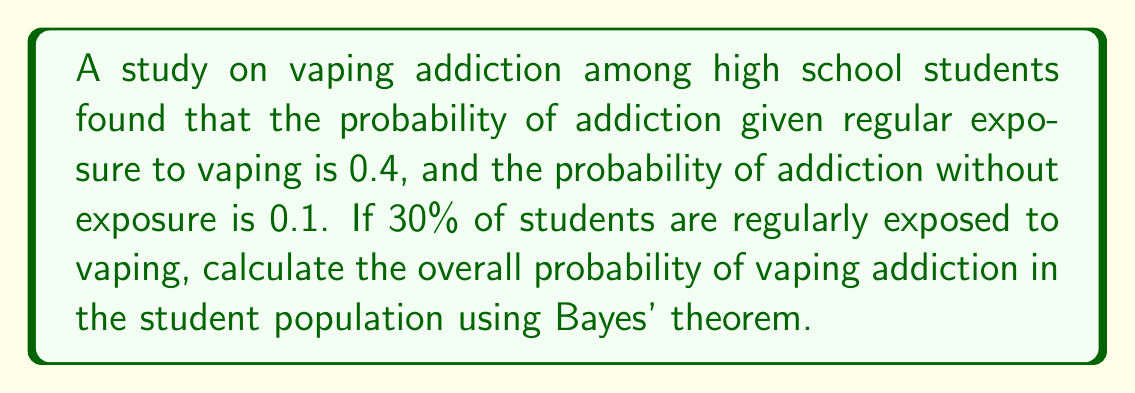Provide a solution to this math problem. To solve this problem, we'll use Bayes' theorem and the law of total probability. Let's define our events:

A: Student becomes addicted to vaping
E: Student is regularly exposed to vaping

Given:
P(A|E) = 0.4 (probability of addiction given exposure)
P(A|not E) = 0.1 (probability of addiction without exposure)
P(E) = 0.3 (probability of exposure)

Step 1: Calculate P(not E)
P(not E) = 1 - P(E) = 1 - 0.3 = 0.7

Step 2: Apply the law of total probability
P(A) = P(A|E) * P(E) + P(A|not E) * P(not E)

Step 3: Substitute the values
P(A) = 0.4 * 0.3 + 0.1 * 0.7

Step 4: Calculate
P(A) = 0.12 + 0.07 = 0.19

Therefore, the overall probability of vaping addiction in the student population is 0.19 or 19%.
Answer: 0.19 